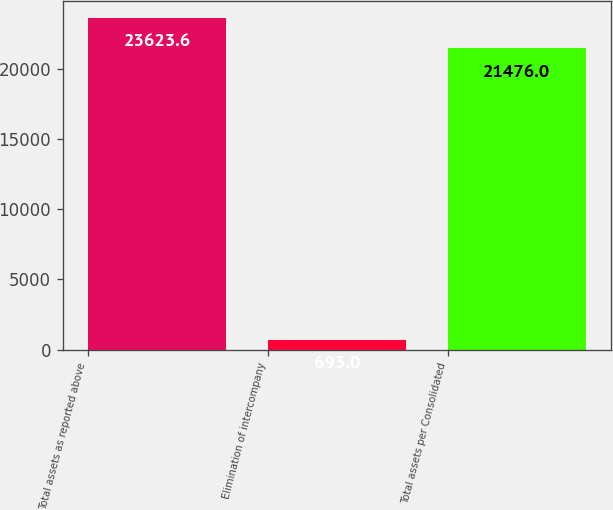Convert chart to OTSL. <chart><loc_0><loc_0><loc_500><loc_500><bar_chart><fcel>Total assets as reported above<fcel>Elimination of intercompany<fcel>Total assets per Consolidated<nl><fcel>23623.6<fcel>693<fcel>21476<nl></chart> 